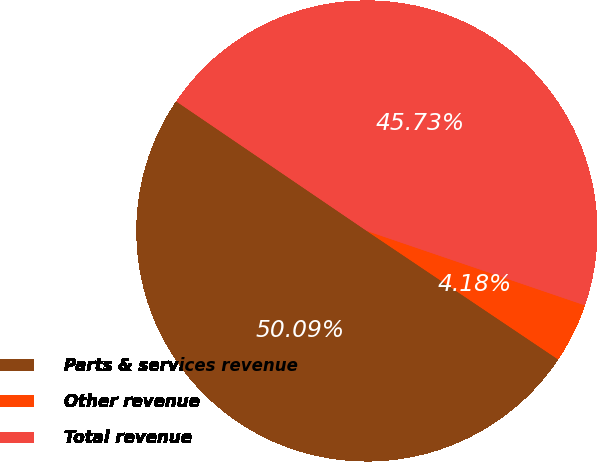<chart> <loc_0><loc_0><loc_500><loc_500><pie_chart><fcel>Parts & services revenue<fcel>Other revenue<fcel>Total revenue<nl><fcel>50.09%<fcel>4.18%<fcel>45.73%<nl></chart> 